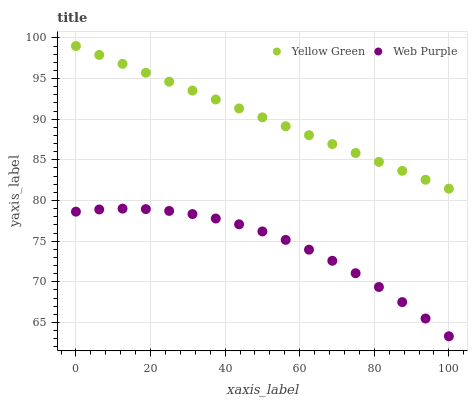Does Web Purple have the minimum area under the curve?
Answer yes or no. Yes. Does Yellow Green have the maximum area under the curve?
Answer yes or no. Yes. Does Yellow Green have the minimum area under the curve?
Answer yes or no. No. Is Yellow Green the smoothest?
Answer yes or no. Yes. Is Web Purple the roughest?
Answer yes or no. Yes. Is Yellow Green the roughest?
Answer yes or no. No. Does Web Purple have the lowest value?
Answer yes or no. Yes. Does Yellow Green have the lowest value?
Answer yes or no. No. Does Yellow Green have the highest value?
Answer yes or no. Yes. Is Web Purple less than Yellow Green?
Answer yes or no. Yes. Is Yellow Green greater than Web Purple?
Answer yes or no. Yes. Does Web Purple intersect Yellow Green?
Answer yes or no. No. 